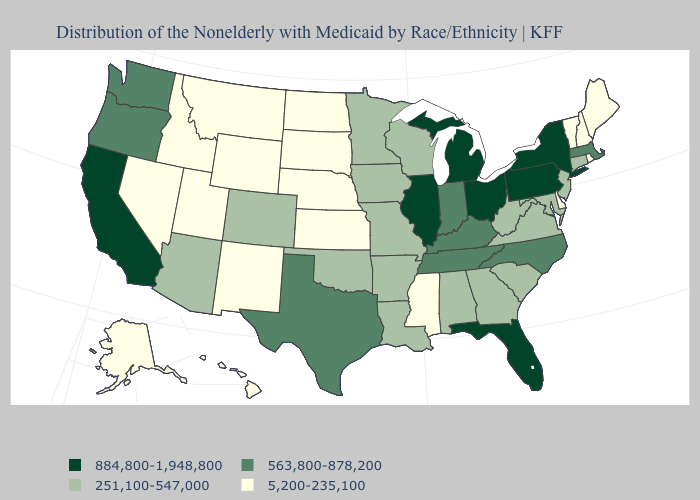What is the value of California?
Short answer required. 884,800-1,948,800. Among the states that border Kansas , which have the highest value?
Be succinct. Colorado, Missouri, Oklahoma. Among the states that border New Mexico , which have the lowest value?
Keep it brief. Utah. Among the states that border Alabama , which have the lowest value?
Short answer required. Mississippi. Among the states that border West Virginia , which have the highest value?
Concise answer only. Ohio, Pennsylvania. What is the lowest value in the Northeast?
Keep it brief. 5,200-235,100. What is the value of Indiana?
Keep it brief. 563,800-878,200. What is the highest value in states that border Minnesota?
Be succinct. 251,100-547,000. Name the states that have a value in the range 251,100-547,000?
Quick response, please. Alabama, Arizona, Arkansas, Colorado, Connecticut, Georgia, Iowa, Louisiana, Maryland, Minnesota, Missouri, New Jersey, Oklahoma, South Carolina, Virginia, West Virginia, Wisconsin. Does the first symbol in the legend represent the smallest category?
Answer briefly. No. What is the highest value in the West ?
Write a very short answer. 884,800-1,948,800. Name the states that have a value in the range 884,800-1,948,800?
Short answer required. California, Florida, Illinois, Michigan, New York, Ohio, Pennsylvania. Among the states that border Wyoming , which have the highest value?
Concise answer only. Colorado. Does Arizona have a lower value than New Jersey?
Write a very short answer. No. What is the value of Vermont?
Concise answer only. 5,200-235,100. 